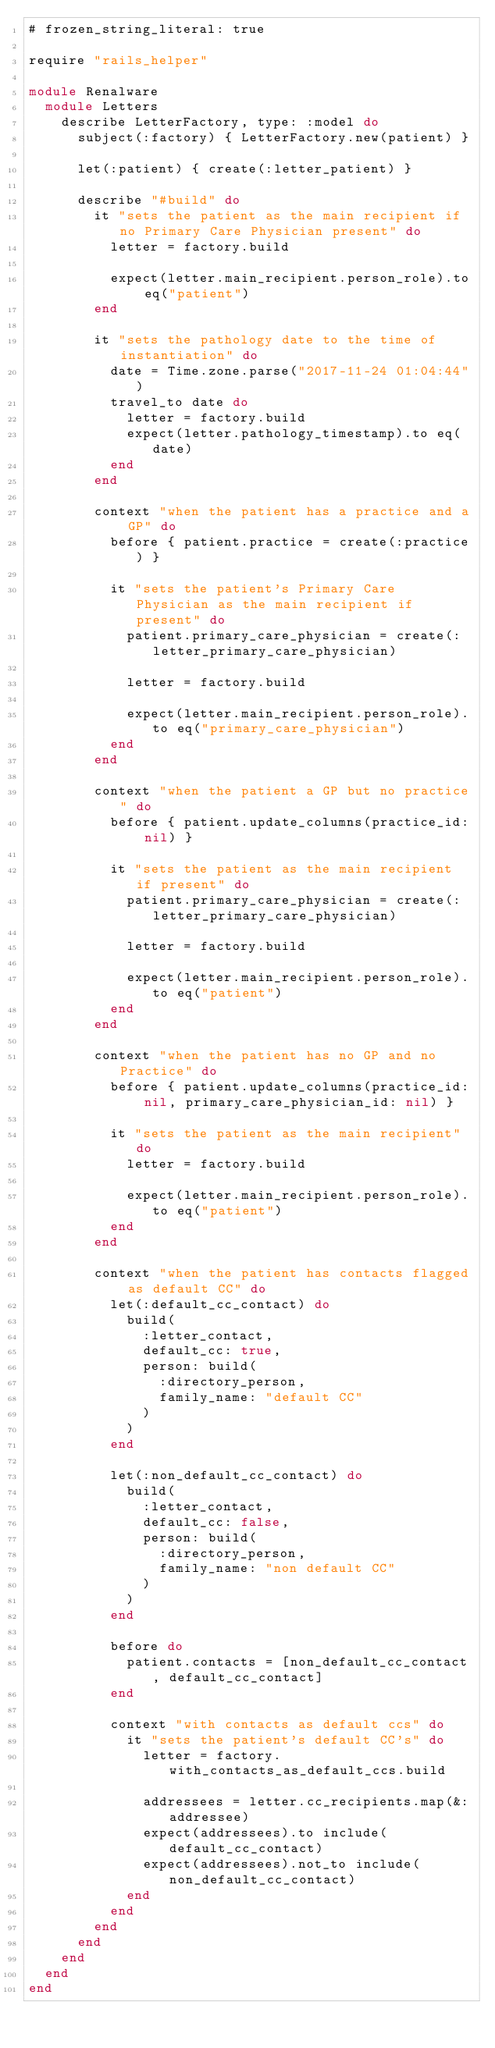Convert code to text. <code><loc_0><loc_0><loc_500><loc_500><_Ruby_># frozen_string_literal: true

require "rails_helper"

module Renalware
  module Letters
    describe LetterFactory, type: :model do
      subject(:factory) { LetterFactory.new(patient) }

      let(:patient) { create(:letter_patient) }

      describe "#build" do
        it "sets the patient as the main recipient if no Primary Care Physician present" do
          letter = factory.build

          expect(letter.main_recipient.person_role).to eq("patient")
        end

        it "sets the pathology date to the time of instantiation" do
          date = Time.zone.parse("2017-11-24 01:04:44")
          travel_to date do
            letter = factory.build
            expect(letter.pathology_timestamp).to eq(date)
          end
        end

        context "when the patient has a practice and a GP" do
          before { patient.practice = create(:practice) }

          it "sets the patient's Primary Care Physician as the main recipient if present" do
            patient.primary_care_physician = create(:letter_primary_care_physician)

            letter = factory.build

            expect(letter.main_recipient.person_role).to eq("primary_care_physician")
          end
        end

        context "when the patient a GP but no practice" do
          before { patient.update_columns(practice_id: nil) }

          it "sets the patient as the main recipient if present" do
            patient.primary_care_physician = create(:letter_primary_care_physician)

            letter = factory.build

            expect(letter.main_recipient.person_role).to eq("patient")
          end
        end

        context "when the patient has no GP and no Practice" do
          before { patient.update_columns(practice_id: nil, primary_care_physician_id: nil) }

          it "sets the patient as the main recipient" do
            letter = factory.build

            expect(letter.main_recipient.person_role).to eq("patient")
          end
        end

        context "when the patient has contacts flagged as default CC" do
          let(:default_cc_contact) do
            build(
              :letter_contact,
              default_cc: true,
              person: build(
                :directory_person,
                family_name: "default CC"
              )
            )
          end

          let(:non_default_cc_contact) do
            build(
              :letter_contact,
              default_cc: false,
              person: build(
                :directory_person,
                family_name: "non default CC"
              )
            )
          end

          before do
            patient.contacts = [non_default_cc_contact, default_cc_contact]
          end

          context "with contacts as default ccs" do
            it "sets the patient's default CC's" do
              letter = factory.with_contacts_as_default_ccs.build

              addressees = letter.cc_recipients.map(&:addressee)
              expect(addressees).to include(default_cc_contact)
              expect(addressees).not_to include(non_default_cc_contact)
            end
          end
        end
      end
    end
  end
end
</code> 